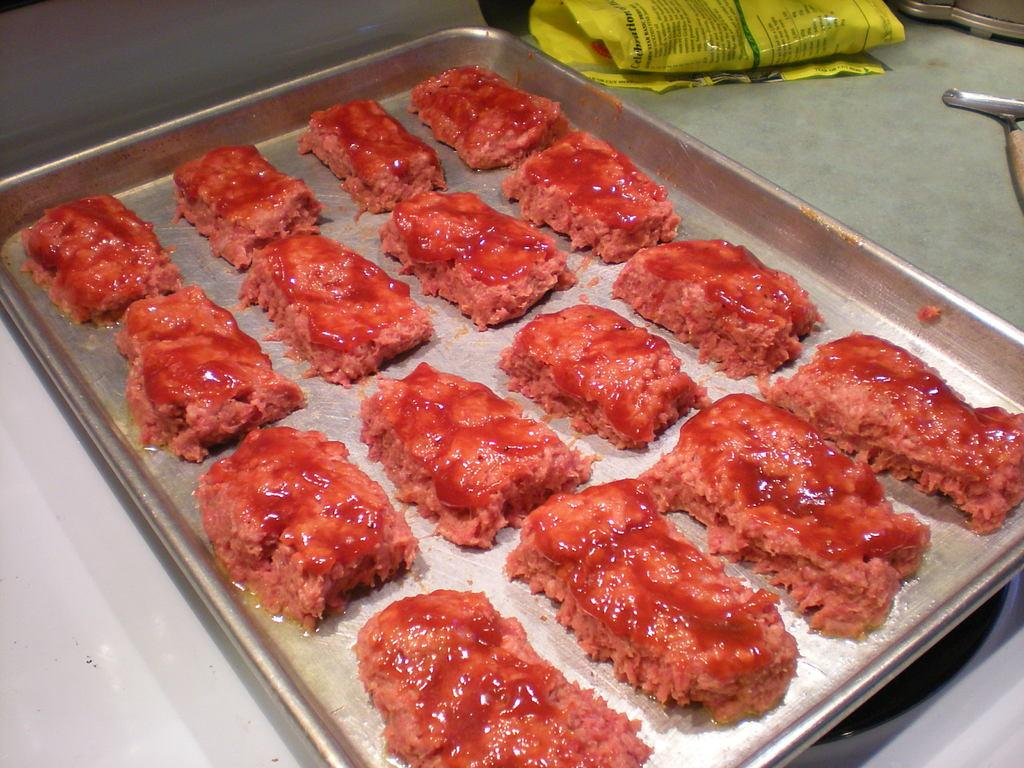What is on the tray that is visible in the image? There is food on a tray in the image. What else can be seen on the desk in the image? There is a cover on a desk in the image. Where is the tray located in the image? The tray is on a stove in the image. How many tickets are visible on the stove in the image? There are no tickets present in the image; it features a tray on a stove. What type of arm is holding the tray on the stove in the image? There is no arm visible in the image; it only shows a tray on a stove. 